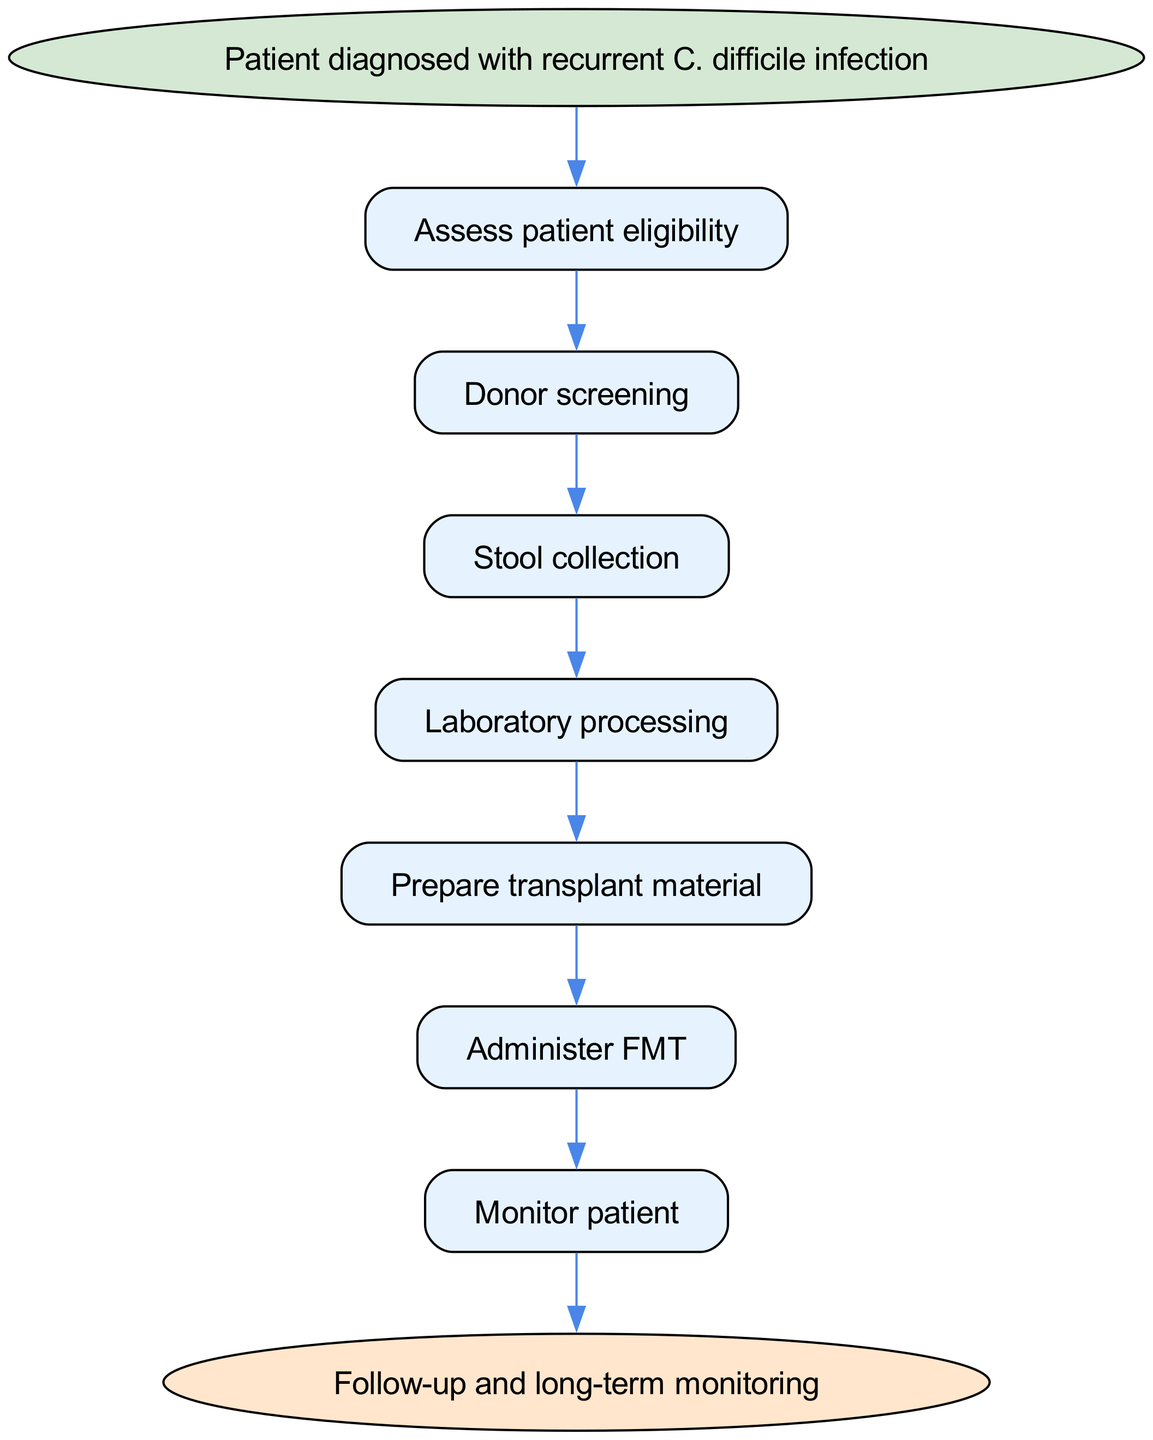What is the starting point of the protocol? The diagram indicates that the protocol begins with the patient being diagnosed with recurrent C. difficile infection, which is specified as the starting node.
Answer: Patient diagnosed with recurrent C. difficile infection How many steps are there in the protocol? By counting the steps listed in the diagram from "Assess patient eligibility" to "Monitor patient," there are a total of 7 steps before reaching the end node.
Answer: 7 What is the final step in the protocol? The end node of the diagram clearly states that the process concludes with "Follow-up and long-term monitoring," indicating what happens after treatment.
Answer: Follow-up and long-term monitoring What follows after "Administer FMT"? The diagram shows that the step that follows "Administer FMT" is "Monitor patient," illustrating the continuation of the protocol.
Answer: Monitor patient Which step comes before "Prepare transplant material"? According to the flow of the diagram, the step before "Prepare transplant material" is "Laboratory processing," showing the sequential order of tasks.
Answer: Laboratory processing What is the relationship between "Donor screening" and "Stool collection"? The diagram indicates that "Donor screening" leads directly to "Stool collection," implying a sequential relationship where one step follows the other.
Answer: Donor screening → Stool collection What is the first action to take in this protocol? The first action outlined in the protocol, as per the flow chart, is to "Assess patient eligibility," showing the importance of evaluating patients before proceeding.
Answer: Assess patient eligibility Which node represents the process of collecting stool? In the diagram, the node labeled "Stool collection" directly represents the action involving the collection of stool samples, which is a critical step in the protocol.
Answer: Stool collection What is the purpose of the "Monitor patient" step? In the context of the flow chart, the "Monitor patient" step serves to ensure patient safety and to observe any reactions or changes post-transplant, which is crucial for evaluating the efficacy of the treatment.
Answer: Monitor patient for reactions and efficacy 